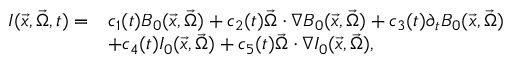<formula> <loc_0><loc_0><loc_500><loc_500>\begin{array} { r l } { I ( \vec { x } , \vec { \Omega } , t ) = } & { c _ { 1 } ( t ) B _ { 0 } ( \vec { x } , \vec { \Omega } ) + c _ { 2 } ( t ) \vec { \Omega } \cdot \nabla B _ { 0 } ( \vec { x } , \vec { \Omega } ) + c _ { 3 } ( t ) \partial _ { t } B _ { 0 } ( \vec { x } , \vec { \Omega } ) } \\ & { + c _ { 4 } ( t ) I _ { 0 } ( \vec { x } , \vec { \Omega } ) + c _ { 5 } ( t ) \vec { \Omega } \cdot \nabla I _ { 0 } ( \vec { x } , \vec { \Omega } ) , } \end{array}</formula> 